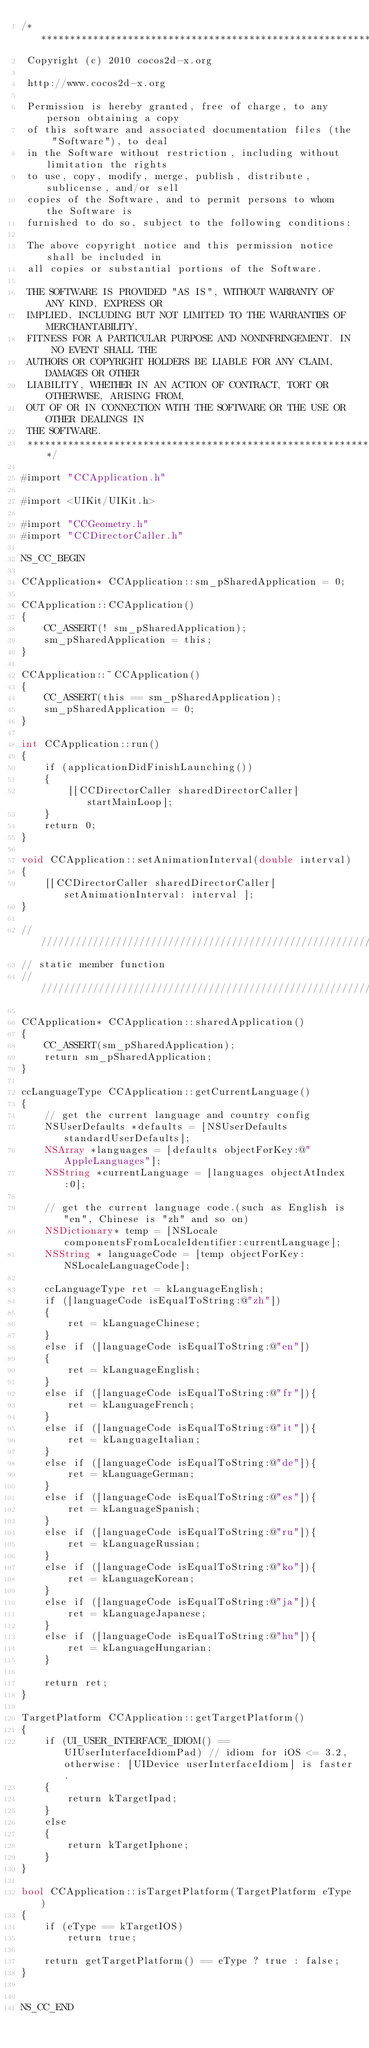<code> <loc_0><loc_0><loc_500><loc_500><_ObjectiveC_>/****************************************************************************
 Copyright (c) 2010 cocos2d-x.org
 
 http://www.cocos2d-x.org
 
 Permission is hereby granted, free of charge, to any person obtaining a copy
 of this software and associated documentation files (the "Software"), to deal
 in the Software without restriction, including without limitation the rights
 to use, copy, modify, merge, publish, distribute, sublicense, and/or sell
 copies of the Software, and to permit persons to whom the Software is
 furnished to do so, subject to the following conditions:
 
 The above copyright notice and this permission notice shall be included in
 all copies or substantial portions of the Software.
 
 THE SOFTWARE IS PROVIDED "AS IS", WITHOUT WARRANTY OF ANY KIND, EXPRESS OR
 IMPLIED, INCLUDING BUT NOT LIMITED TO THE WARRANTIES OF MERCHANTABILITY,
 FITNESS FOR A PARTICULAR PURPOSE AND NONINFRINGEMENT. IN NO EVENT SHALL THE
 AUTHORS OR COPYRIGHT HOLDERS BE LIABLE FOR ANY CLAIM, DAMAGES OR OTHER
 LIABILITY, WHETHER IN AN ACTION OF CONTRACT, TORT OR OTHERWISE, ARISING FROM,
 OUT OF OR IN CONNECTION WITH THE SOFTWARE OR THE USE OR OTHER DEALINGS IN
 THE SOFTWARE.
 ****************************************************************************/

#import "CCApplication.h"

#import <UIKit/UIKit.h>

#import "CCGeometry.h"
#import "CCDirectorCaller.h"

NS_CC_BEGIN

CCApplication* CCApplication::sm_pSharedApplication = 0;

CCApplication::CCApplication()
{
    CC_ASSERT(! sm_pSharedApplication);
    sm_pSharedApplication = this;
}

CCApplication::~CCApplication()
{
    CC_ASSERT(this == sm_pSharedApplication);
    sm_pSharedApplication = 0;
}

int CCApplication::run()
{
    if (applicationDidFinishLaunching()) 
    {
        [[CCDirectorCaller sharedDirectorCaller] startMainLoop];
    }
    return 0;
}

void CCApplication::setAnimationInterval(double interval)
{
    [[CCDirectorCaller sharedDirectorCaller] setAnimationInterval: interval ];
}

/////////////////////////////////////////////////////////////////////////////////////////////////
// static member function
//////////////////////////////////////////////////////////////////////////////////////////////////

CCApplication* CCApplication::sharedApplication()
{
    CC_ASSERT(sm_pSharedApplication);
    return sm_pSharedApplication;
}

ccLanguageType CCApplication::getCurrentLanguage()
{
    // get the current language and country config
    NSUserDefaults *defaults = [NSUserDefaults standardUserDefaults];
    NSArray *languages = [defaults objectForKey:@"AppleLanguages"];
    NSString *currentLanguage = [languages objectAtIndex:0];

    // get the current language code.(such as English is "en", Chinese is "zh" and so on)
    NSDictionary* temp = [NSLocale componentsFromLocaleIdentifier:currentLanguage];
    NSString * languageCode = [temp objectForKey:NSLocaleLanguageCode];

    ccLanguageType ret = kLanguageEnglish;
    if ([languageCode isEqualToString:@"zh"])
    {
        ret = kLanguageChinese;
    }
    else if ([languageCode isEqualToString:@"en"])
    {
        ret = kLanguageEnglish;
    }
    else if ([languageCode isEqualToString:@"fr"]){
        ret = kLanguageFrench;
    }
    else if ([languageCode isEqualToString:@"it"]){
        ret = kLanguageItalian;
    }
    else if ([languageCode isEqualToString:@"de"]){
        ret = kLanguageGerman;
    }
    else if ([languageCode isEqualToString:@"es"]){
        ret = kLanguageSpanish;
    }
    else if ([languageCode isEqualToString:@"ru"]){
        ret = kLanguageRussian;
    }
    else if ([languageCode isEqualToString:@"ko"]){
        ret = kLanguageKorean;
    }
    else if ([languageCode isEqualToString:@"ja"]){
        ret = kLanguageJapanese;
    }
    else if ([languageCode isEqualToString:@"hu"]){
        ret = kLanguageHungarian;
    }

    return ret;
}

TargetPlatform CCApplication::getTargetPlatform()
{
    if (UI_USER_INTERFACE_IDIOM() == UIUserInterfaceIdiomPad) // idiom for iOS <= 3.2, otherwise: [UIDevice userInterfaceIdiom] is faster.
    {
        return kTargetIpad;
    }
    else 
    {
        return kTargetIphone;
    }
}

bool CCApplication::isTargetPlatform(TargetPlatform eType)
{
    if (eType == kTargetIOS)
        return true;
    
    return getTargetPlatform() == eType ? true : false;
}


NS_CC_END
</code> 